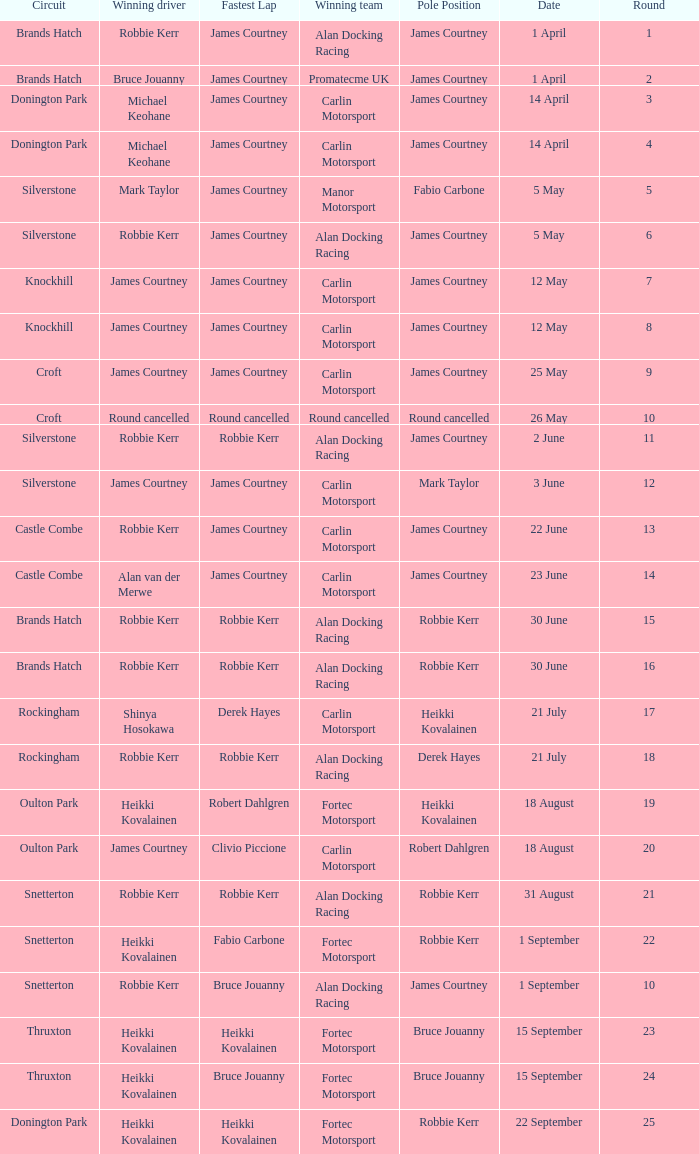What is every pole position for the Castle Combe circuit and Robbie Kerr is the winning driver? James Courtney. 